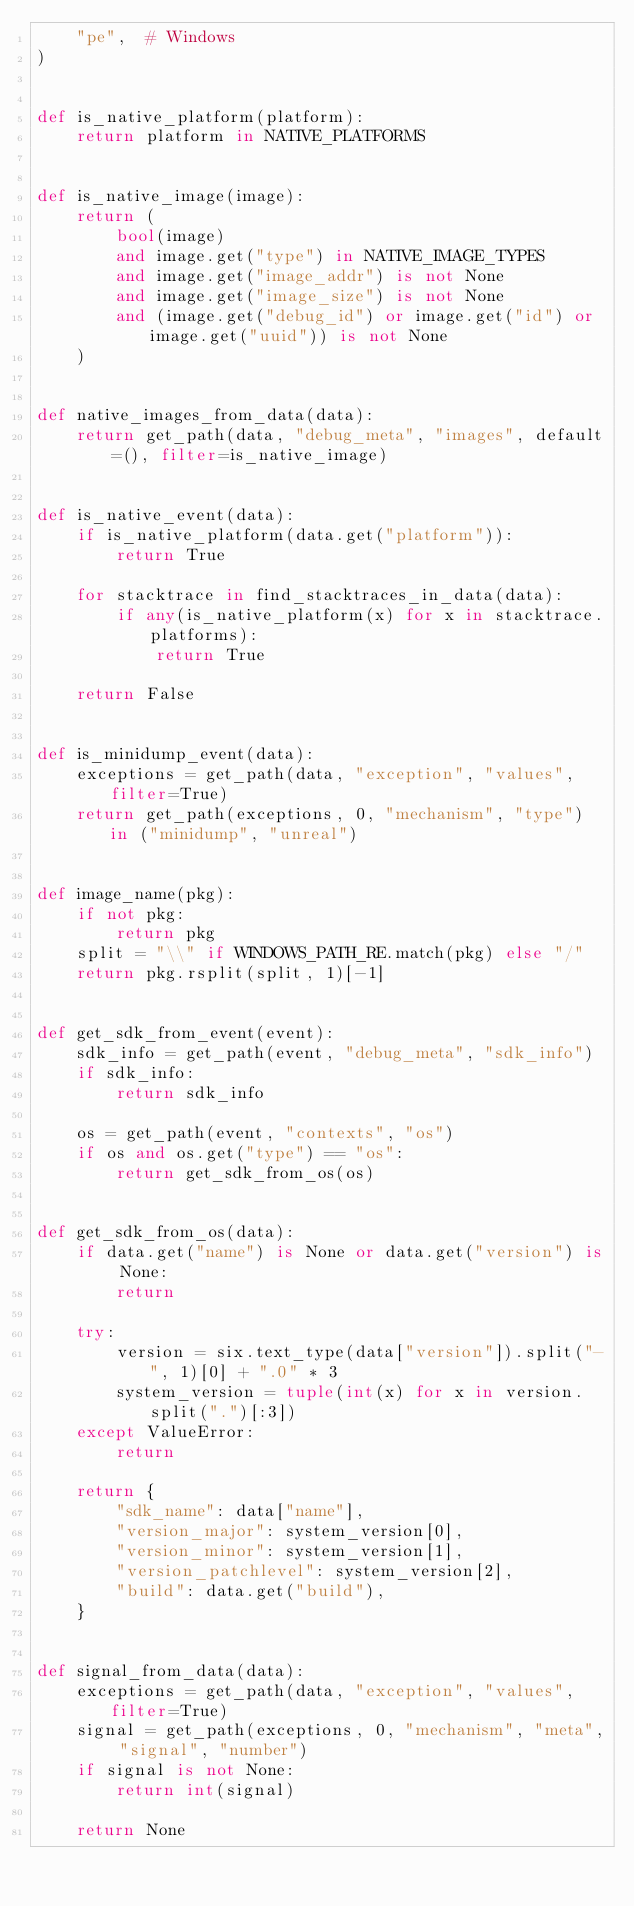<code> <loc_0><loc_0><loc_500><loc_500><_Python_>    "pe",  # Windows
)


def is_native_platform(platform):
    return platform in NATIVE_PLATFORMS


def is_native_image(image):
    return (
        bool(image)
        and image.get("type") in NATIVE_IMAGE_TYPES
        and image.get("image_addr") is not None
        and image.get("image_size") is not None
        and (image.get("debug_id") or image.get("id") or image.get("uuid")) is not None
    )


def native_images_from_data(data):
    return get_path(data, "debug_meta", "images", default=(), filter=is_native_image)


def is_native_event(data):
    if is_native_platform(data.get("platform")):
        return True

    for stacktrace in find_stacktraces_in_data(data):
        if any(is_native_platform(x) for x in stacktrace.platforms):
            return True

    return False


def is_minidump_event(data):
    exceptions = get_path(data, "exception", "values", filter=True)
    return get_path(exceptions, 0, "mechanism", "type") in ("minidump", "unreal")


def image_name(pkg):
    if not pkg:
        return pkg
    split = "\\" if WINDOWS_PATH_RE.match(pkg) else "/"
    return pkg.rsplit(split, 1)[-1]


def get_sdk_from_event(event):
    sdk_info = get_path(event, "debug_meta", "sdk_info")
    if sdk_info:
        return sdk_info

    os = get_path(event, "contexts", "os")
    if os and os.get("type") == "os":
        return get_sdk_from_os(os)


def get_sdk_from_os(data):
    if data.get("name") is None or data.get("version") is None:
        return

    try:
        version = six.text_type(data["version"]).split("-", 1)[0] + ".0" * 3
        system_version = tuple(int(x) for x in version.split(".")[:3])
    except ValueError:
        return

    return {
        "sdk_name": data["name"],
        "version_major": system_version[0],
        "version_minor": system_version[1],
        "version_patchlevel": system_version[2],
        "build": data.get("build"),
    }


def signal_from_data(data):
    exceptions = get_path(data, "exception", "values", filter=True)
    signal = get_path(exceptions, 0, "mechanism", "meta", "signal", "number")
    if signal is not None:
        return int(signal)

    return None
</code> 